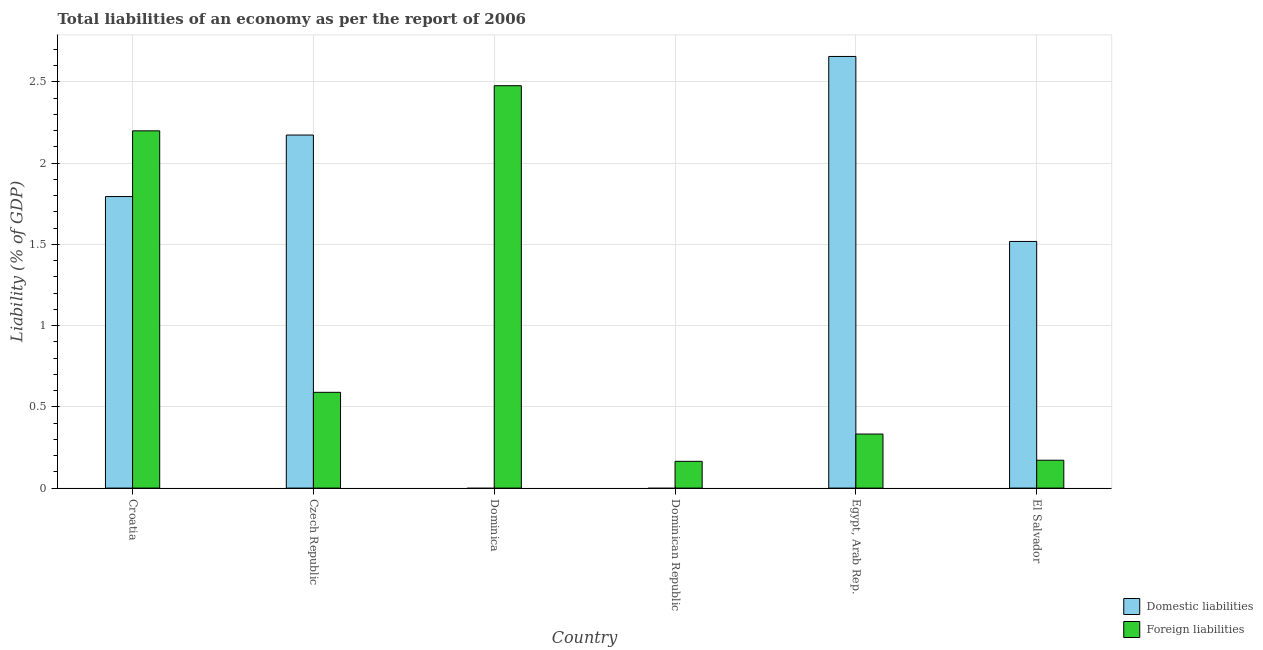How many different coloured bars are there?
Your answer should be compact. 2. Are the number of bars on each tick of the X-axis equal?
Provide a short and direct response. No. What is the label of the 4th group of bars from the left?
Give a very brief answer. Dominican Republic. In how many cases, is the number of bars for a given country not equal to the number of legend labels?
Give a very brief answer. 2. What is the incurrence of domestic liabilities in Czech Republic?
Provide a short and direct response. 2.17. Across all countries, what is the maximum incurrence of domestic liabilities?
Offer a very short reply. 2.66. Across all countries, what is the minimum incurrence of foreign liabilities?
Your answer should be very brief. 0.16. In which country was the incurrence of domestic liabilities maximum?
Provide a short and direct response. Egypt, Arab Rep. What is the total incurrence of domestic liabilities in the graph?
Keep it short and to the point. 8.14. What is the difference between the incurrence of foreign liabilities in Dominican Republic and that in Egypt, Arab Rep.?
Provide a short and direct response. -0.17. What is the difference between the incurrence of domestic liabilities in Croatia and the incurrence of foreign liabilities in Czech Republic?
Your response must be concise. 1.2. What is the average incurrence of domestic liabilities per country?
Make the answer very short. 1.36. What is the difference between the incurrence of foreign liabilities and incurrence of domestic liabilities in Czech Republic?
Your response must be concise. -1.58. In how many countries, is the incurrence of foreign liabilities greater than 0.6 %?
Your answer should be very brief. 2. What is the ratio of the incurrence of foreign liabilities in Croatia to that in Czech Republic?
Your answer should be compact. 3.73. Is the incurrence of foreign liabilities in Dominican Republic less than that in Egypt, Arab Rep.?
Provide a succinct answer. Yes. Is the difference between the incurrence of domestic liabilities in Croatia and Czech Republic greater than the difference between the incurrence of foreign liabilities in Croatia and Czech Republic?
Keep it short and to the point. No. What is the difference between the highest and the second highest incurrence of foreign liabilities?
Offer a terse response. 0.28. What is the difference between the highest and the lowest incurrence of domestic liabilities?
Give a very brief answer. 2.66. How many bars are there?
Provide a succinct answer. 10. What is the difference between two consecutive major ticks on the Y-axis?
Offer a very short reply. 0.5. Are the values on the major ticks of Y-axis written in scientific E-notation?
Your answer should be compact. No. Does the graph contain grids?
Your answer should be very brief. Yes. What is the title of the graph?
Make the answer very short. Total liabilities of an economy as per the report of 2006. What is the label or title of the Y-axis?
Keep it short and to the point. Liability (% of GDP). What is the Liability (% of GDP) of Domestic liabilities in Croatia?
Give a very brief answer. 1.79. What is the Liability (% of GDP) in Foreign liabilities in Croatia?
Provide a short and direct response. 2.2. What is the Liability (% of GDP) in Domestic liabilities in Czech Republic?
Provide a short and direct response. 2.17. What is the Liability (% of GDP) in Foreign liabilities in Czech Republic?
Ensure brevity in your answer.  0.59. What is the Liability (% of GDP) of Domestic liabilities in Dominica?
Offer a terse response. 0. What is the Liability (% of GDP) in Foreign liabilities in Dominica?
Offer a very short reply. 2.48. What is the Liability (% of GDP) of Domestic liabilities in Dominican Republic?
Offer a very short reply. 0. What is the Liability (% of GDP) in Foreign liabilities in Dominican Republic?
Your answer should be very brief. 0.16. What is the Liability (% of GDP) in Domestic liabilities in Egypt, Arab Rep.?
Your answer should be compact. 2.66. What is the Liability (% of GDP) of Foreign liabilities in Egypt, Arab Rep.?
Offer a terse response. 0.33. What is the Liability (% of GDP) in Domestic liabilities in El Salvador?
Your answer should be compact. 1.52. What is the Liability (% of GDP) of Foreign liabilities in El Salvador?
Your response must be concise. 0.17. Across all countries, what is the maximum Liability (% of GDP) of Domestic liabilities?
Provide a succinct answer. 2.66. Across all countries, what is the maximum Liability (% of GDP) in Foreign liabilities?
Give a very brief answer. 2.48. Across all countries, what is the minimum Liability (% of GDP) in Foreign liabilities?
Your answer should be very brief. 0.16. What is the total Liability (% of GDP) of Domestic liabilities in the graph?
Offer a very short reply. 8.14. What is the total Liability (% of GDP) of Foreign liabilities in the graph?
Make the answer very short. 5.93. What is the difference between the Liability (% of GDP) of Domestic liabilities in Croatia and that in Czech Republic?
Your response must be concise. -0.38. What is the difference between the Liability (% of GDP) of Foreign liabilities in Croatia and that in Czech Republic?
Ensure brevity in your answer.  1.61. What is the difference between the Liability (% of GDP) of Foreign liabilities in Croatia and that in Dominica?
Ensure brevity in your answer.  -0.28. What is the difference between the Liability (% of GDP) in Foreign liabilities in Croatia and that in Dominican Republic?
Give a very brief answer. 2.03. What is the difference between the Liability (% of GDP) in Domestic liabilities in Croatia and that in Egypt, Arab Rep.?
Your answer should be very brief. -0.86. What is the difference between the Liability (% of GDP) in Foreign liabilities in Croatia and that in Egypt, Arab Rep.?
Ensure brevity in your answer.  1.87. What is the difference between the Liability (% of GDP) of Domestic liabilities in Croatia and that in El Salvador?
Make the answer very short. 0.28. What is the difference between the Liability (% of GDP) in Foreign liabilities in Croatia and that in El Salvador?
Offer a very short reply. 2.03. What is the difference between the Liability (% of GDP) of Foreign liabilities in Czech Republic and that in Dominica?
Provide a succinct answer. -1.89. What is the difference between the Liability (% of GDP) in Foreign liabilities in Czech Republic and that in Dominican Republic?
Your answer should be very brief. 0.42. What is the difference between the Liability (% of GDP) in Domestic liabilities in Czech Republic and that in Egypt, Arab Rep.?
Offer a terse response. -0.48. What is the difference between the Liability (% of GDP) in Foreign liabilities in Czech Republic and that in Egypt, Arab Rep.?
Give a very brief answer. 0.26. What is the difference between the Liability (% of GDP) in Domestic liabilities in Czech Republic and that in El Salvador?
Provide a short and direct response. 0.65. What is the difference between the Liability (% of GDP) of Foreign liabilities in Czech Republic and that in El Salvador?
Provide a short and direct response. 0.42. What is the difference between the Liability (% of GDP) of Foreign liabilities in Dominica and that in Dominican Republic?
Offer a very short reply. 2.31. What is the difference between the Liability (% of GDP) in Foreign liabilities in Dominica and that in Egypt, Arab Rep.?
Your answer should be compact. 2.14. What is the difference between the Liability (% of GDP) of Foreign liabilities in Dominica and that in El Salvador?
Provide a succinct answer. 2.31. What is the difference between the Liability (% of GDP) of Foreign liabilities in Dominican Republic and that in Egypt, Arab Rep.?
Provide a short and direct response. -0.17. What is the difference between the Liability (% of GDP) of Foreign liabilities in Dominican Republic and that in El Salvador?
Your answer should be compact. -0.01. What is the difference between the Liability (% of GDP) in Domestic liabilities in Egypt, Arab Rep. and that in El Salvador?
Provide a succinct answer. 1.14. What is the difference between the Liability (% of GDP) of Foreign liabilities in Egypt, Arab Rep. and that in El Salvador?
Provide a short and direct response. 0.16. What is the difference between the Liability (% of GDP) in Domestic liabilities in Croatia and the Liability (% of GDP) in Foreign liabilities in Czech Republic?
Ensure brevity in your answer.  1.2. What is the difference between the Liability (% of GDP) of Domestic liabilities in Croatia and the Liability (% of GDP) of Foreign liabilities in Dominica?
Offer a terse response. -0.68. What is the difference between the Liability (% of GDP) of Domestic liabilities in Croatia and the Liability (% of GDP) of Foreign liabilities in Dominican Republic?
Your response must be concise. 1.63. What is the difference between the Liability (% of GDP) of Domestic liabilities in Croatia and the Liability (% of GDP) of Foreign liabilities in Egypt, Arab Rep.?
Ensure brevity in your answer.  1.46. What is the difference between the Liability (% of GDP) of Domestic liabilities in Croatia and the Liability (% of GDP) of Foreign liabilities in El Salvador?
Your answer should be compact. 1.62. What is the difference between the Liability (% of GDP) in Domestic liabilities in Czech Republic and the Liability (% of GDP) in Foreign liabilities in Dominica?
Make the answer very short. -0.3. What is the difference between the Liability (% of GDP) of Domestic liabilities in Czech Republic and the Liability (% of GDP) of Foreign liabilities in Dominican Republic?
Your answer should be very brief. 2.01. What is the difference between the Liability (% of GDP) in Domestic liabilities in Czech Republic and the Liability (% of GDP) in Foreign liabilities in Egypt, Arab Rep.?
Provide a succinct answer. 1.84. What is the difference between the Liability (% of GDP) of Domestic liabilities in Czech Republic and the Liability (% of GDP) of Foreign liabilities in El Salvador?
Make the answer very short. 2. What is the difference between the Liability (% of GDP) of Domestic liabilities in Egypt, Arab Rep. and the Liability (% of GDP) of Foreign liabilities in El Salvador?
Your answer should be very brief. 2.48. What is the average Liability (% of GDP) of Domestic liabilities per country?
Offer a terse response. 1.36. What is the average Liability (% of GDP) of Foreign liabilities per country?
Offer a very short reply. 0.99. What is the difference between the Liability (% of GDP) of Domestic liabilities and Liability (% of GDP) of Foreign liabilities in Croatia?
Offer a terse response. -0.4. What is the difference between the Liability (% of GDP) in Domestic liabilities and Liability (% of GDP) in Foreign liabilities in Czech Republic?
Give a very brief answer. 1.58. What is the difference between the Liability (% of GDP) of Domestic liabilities and Liability (% of GDP) of Foreign liabilities in Egypt, Arab Rep.?
Offer a terse response. 2.32. What is the difference between the Liability (% of GDP) of Domestic liabilities and Liability (% of GDP) of Foreign liabilities in El Salvador?
Your answer should be very brief. 1.35. What is the ratio of the Liability (% of GDP) in Domestic liabilities in Croatia to that in Czech Republic?
Make the answer very short. 0.83. What is the ratio of the Liability (% of GDP) in Foreign liabilities in Croatia to that in Czech Republic?
Keep it short and to the point. 3.73. What is the ratio of the Liability (% of GDP) in Foreign liabilities in Croatia to that in Dominica?
Offer a very short reply. 0.89. What is the ratio of the Liability (% of GDP) in Foreign liabilities in Croatia to that in Dominican Republic?
Offer a terse response. 13.35. What is the ratio of the Liability (% of GDP) in Domestic liabilities in Croatia to that in Egypt, Arab Rep.?
Provide a short and direct response. 0.68. What is the ratio of the Liability (% of GDP) of Foreign liabilities in Croatia to that in Egypt, Arab Rep.?
Offer a terse response. 6.61. What is the ratio of the Liability (% of GDP) of Domestic liabilities in Croatia to that in El Salvador?
Your answer should be compact. 1.18. What is the ratio of the Liability (% of GDP) in Foreign liabilities in Croatia to that in El Salvador?
Make the answer very short. 12.82. What is the ratio of the Liability (% of GDP) in Foreign liabilities in Czech Republic to that in Dominica?
Your answer should be compact. 0.24. What is the ratio of the Liability (% of GDP) of Foreign liabilities in Czech Republic to that in Dominican Republic?
Ensure brevity in your answer.  3.58. What is the ratio of the Liability (% of GDP) in Domestic liabilities in Czech Republic to that in Egypt, Arab Rep.?
Ensure brevity in your answer.  0.82. What is the ratio of the Liability (% of GDP) of Foreign liabilities in Czech Republic to that in Egypt, Arab Rep.?
Offer a terse response. 1.77. What is the ratio of the Liability (% of GDP) of Domestic liabilities in Czech Republic to that in El Salvador?
Your response must be concise. 1.43. What is the ratio of the Liability (% of GDP) in Foreign liabilities in Czech Republic to that in El Salvador?
Give a very brief answer. 3.44. What is the ratio of the Liability (% of GDP) of Foreign liabilities in Dominica to that in Dominican Republic?
Your answer should be very brief. 15.04. What is the ratio of the Liability (% of GDP) of Foreign liabilities in Dominica to that in Egypt, Arab Rep.?
Provide a succinct answer. 7.44. What is the ratio of the Liability (% of GDP) of Foreign liabilities in Dominica to that in El Salvador?
Provide a short and direct response. 14.44. What is the ratio of the Liability (% of GDP) of Foreign liabilities in Dominican Republic to that in Egypt, Arab Rep.?
Make the answer very short. 0.49. What is the ratio of the Liability (% of GDP) in Foreign liabilities in Dominican Republic to that in El Salvador?
Provide a short and direct response. 0.96. What is the ratio of the Liability (% of GDP) in Domestic liabilities in Egypt, Arab Rep. to that in El Salvador?
Provide a succinct answer. 1.75. What is the ratio of the Liability (% of GDP) in Foreign liabilities in Egypt, Arab Rep. to that in El Salvador?
Your answer should be compact. 1.94. What is the difference between the highest and the second highest Liability (% of GDP) in Domestic liabilities?
Offer a terse response. 0.48. What is the difference between the highest and the second highest Liability (% of GDP) in Foreign liabilities?
Your response must be concise. 0.28. What is the difference between the highest and the lowest Liability (% of GDP) in Domestic liabilities?
Your answer should be very brief. 2.66. What is the difference between the highest and the lowest Liability (% of GDP) in Foreign liabilities?
Give a very brief answer. 2.31. 